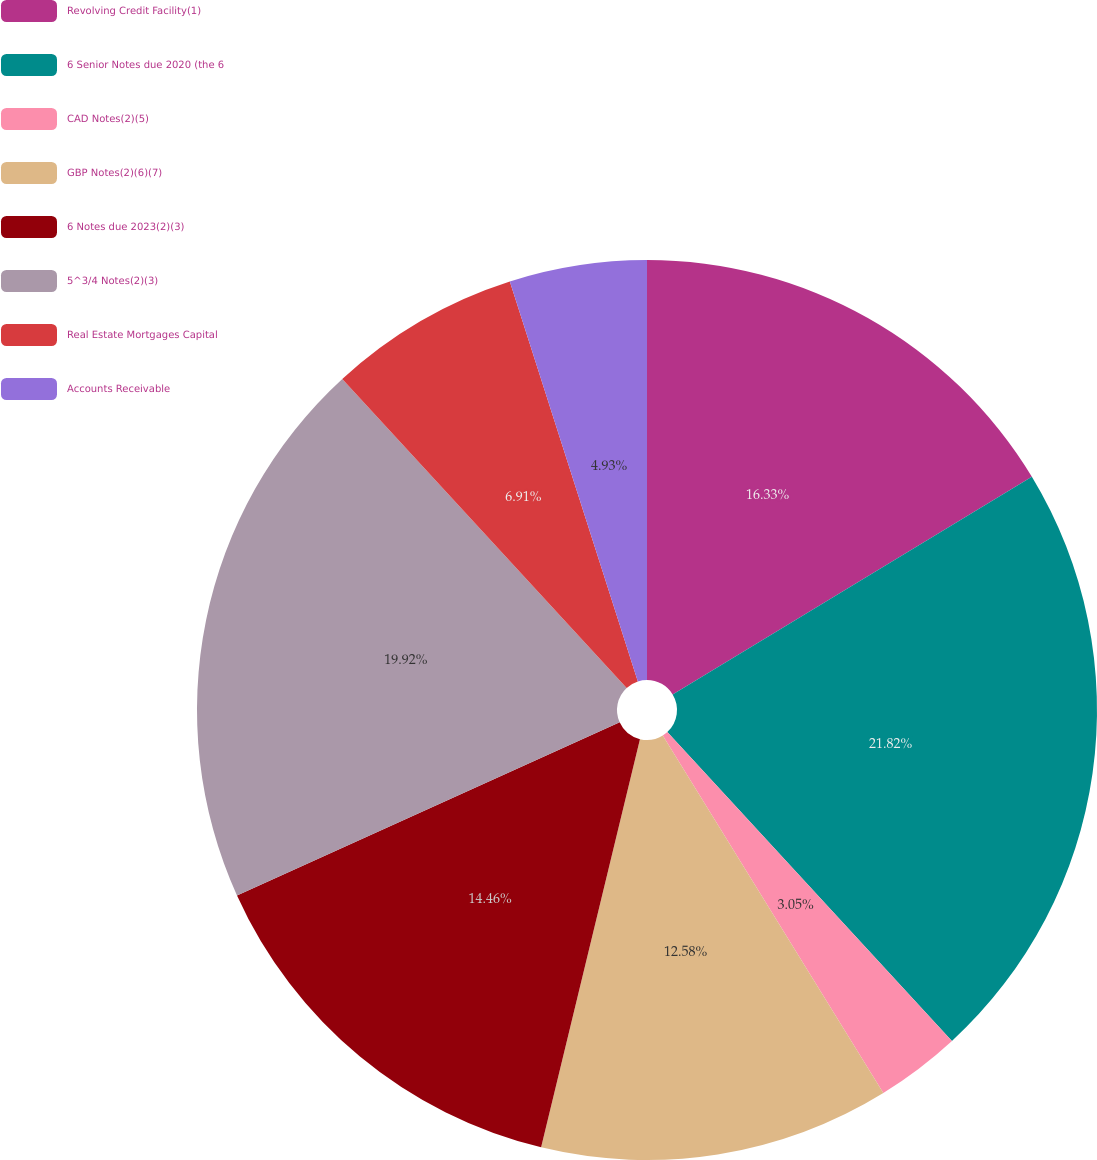Convert chart to OTSL. <chart><loc_0><loc_0><loc_500><loc_500><pie_chart><fcel>Revolving Credit Facility(1)<fcel>6 Senior Notes due 2020 (the 6<fcel>CAD Notes(2)(5)<fcel>GBP Notes(2)(6)(7)<fcel>6 Notes due 2023(2)(3)<fcel>5^3/4 Notes(2)(3)<fcel>Real Estate Mortgages Capital<fcel>Accounts Receivable<nl><fcel>16.33%<fcel>21.82%<fcel>3.05%<fcel>12.58%<fcel>14.46%<fcel>19.92%<fcel>6.91%<fcel>4.93%<nl></chart> 